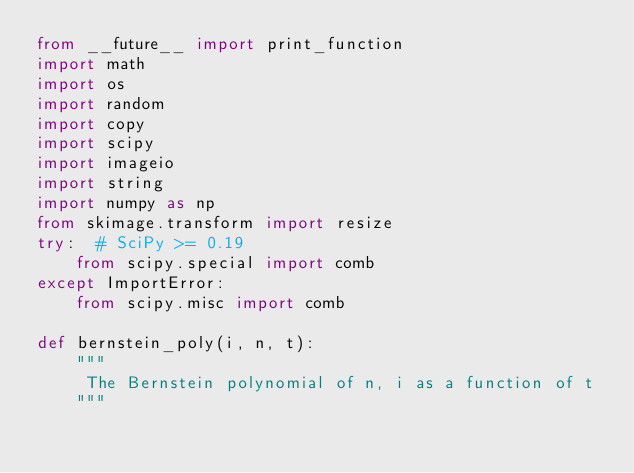Convert code to text. <code><loc_0><loc_0><loc_500><loc_500><_Python_>from __future__ import print_function
import math
import os
import random
import copy
import scipy
import imageio
import string
import numpy as np
from skimage.transform import resize
try:  # SciPy >= 0.19
    from scipy.special import comb
except ImportError:
    from scipy.misc import comb

def bernstein_poly(i, n, t):
    """
     The Bernstein polynomial of n, i as a function of t
    """
</code> 